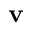<formula> <loc_0><loc_0><loc_500><loc_500>v</formula> 